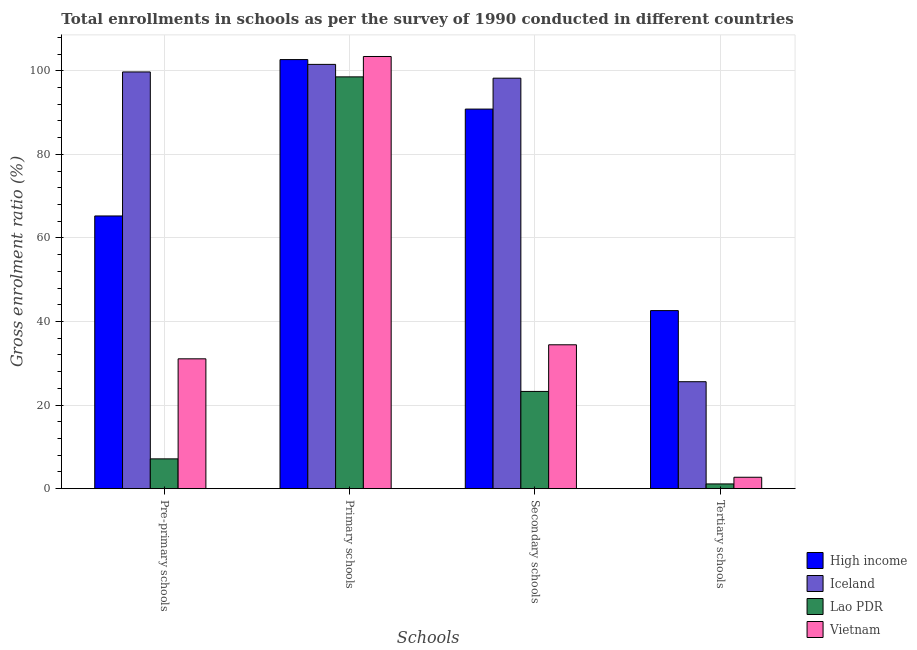Are the number of bars per tick equal to the number of legend labels?
Keep it short and to the point. Yes. How many bars are there on the 2nd tick from the left?
Provide a succinct answer. 4. What is the label of the 4th group of bars from the left?
Your answer should be very brief. Tertiary schools. What is the gross enrolment ratio in secondary schools in Iceland?
Offer a terse response. 98.23. Across all countries, what is the maximum gross enrolment ratio in pre-primary schools?
Ensure brevity in your answer.  99.72. Across all countries, what is the minimum gross enrolment ratio in tertiary schools?
Provide a succinct answer. 1.13. In which country was the gross enrolment ratio in tertiary schools maximum?
Ensure brevity in your answer.  High income. In which country was the gross enrolment ratio in secondary schools minimum?
Give a very brief answer. Lao PDR. What is the total gross enrolment ratio in primary schools in the graph?
Make the answer very short. 406.16. What is the difference between the gross enrolment ratio in pre-primary schools in Lao PDR and that in Vietnam?
Offer a very short reply. -23.94. What is the difference between the gross enrolment ratio in primary schools in Iceland and the gross enrolment ratio in pre-primary schools in High income?
Your response must be concise. 36.27. What is the average gross enrolment ratio in tertiary schools per country?
Provide a short and direct response. 18.02. What is the difference between the gross enrolment ratio in primary schools and gross enrolment ratio in tertiary schools in High income?
Your answer should be very brief. 60.06. What is the ratio of the gross enrolment ratio in secondary schools in Iceland to that in Vietnam?
Your answer should be compact. 2.85. What is the difference between the highest and the second highest gross enrolment ratio in primary schools?
Offer a terse response. 0.74. What is the difference between the highest and the lowest gross enrolment ratio in tertiary schools?
Provide a short and direct response. 41.48. Is the sum of the gross enrolment ratio in secondary schools in Vietnam and Iceland greater than the maximum gross enrolment ratio in pre-primary schools across all countries?
Keep it short and to the point. Yes. Is it the case that in every country, the sum of the gross enrolment ratio in tertiary schools and gross enrolment ratio in secondary schools is greater than the sum of gross enrolment ratio in pre-primary schools and gross enrolment ratio in primary schools?
Your response must be concise. No. What does the 4th bar from the left in Primary schools represents?
Keep it short and to the point. Vietnam. What does the 2nd bar from the right in Tertiary schools represents?
Offer a very short reply. Lao PDR. Are the values on the major ticks of Y-axis written in scientific E-notation?
Provide a short and direct response. No. Does the graph contain grids?
Offer a terse response. Yes. Where does the legend appear in the graph?
Ensure brevity in your answer.  Bottom right. How many legend labels are there?
Your response must be concise. 4. How are the legend labels stacked?
Make the answer very short. Vertical. What is the title of the graph?
Ensure brevity in your answer.  Total enrollments in schools as per the survey of 1990 conducted in different countries. Does "Sudan" appear as one of the legend labels in the graph?
Offer a terse response. No. What is the label or title of the X-axis?
Your answer should be compact. Schools. What is the Gross enrolment ratio (%) of High income in Pre-primary schools?
Provide a succinct answer. 65.26. What is the Gross enrolment ratio (%) in Iceland in Pre-primary schools?
Your response must be concise. 99.72. What is the Gross enrolment ratio (%) of Lao PDR in Pre-primary schools?
Make the answer very short. 7.13. What is the Gross enrolment ratio (%) in Vietnam in Pre-primary schools?
Keep it short and to the point. 31.07. What is the Gross enrolment ratio (%) in High income in Primary schools?
Give a very brief answer. 102.68. What is the Gross enrolment ratio (%) in Iceland in Primary schools?
Offer a very short reply. 101.53. What is the Gross enrolment ratio (%) in Lao PDR in Primary schools?
Your response must be concise. 98.54. What is the Gross enrolment ratio (%) in Vietnam in Primary schools?
Provide a short and direct response. 103.42. What is the Gross enrolment ratio (%) in High income in Secondary schools?
Your answer should be compact. 90.83. What is the Gross enrolment ratio (%) of Iceland in Secondary schools?
Make the answer very short. 98.23. What is the Gross enrolment ratio (%) of Lao PDR in Secondary schools?
Provide a short and direct response. 23.27. What is the Gross enrolment ratio (%) of Vietnam in Secondary schools?
Offer a terse response. 34.43. What is the Gross enrolment ratio (%) of High income in Tertiary schools?
Offer a very short reply. 42.61. What is the Gross enrolment ratio (%) in Iceland in Tertiary schools?
Your answer should be compact. 25.6. What is the Gross enrolment ratio (%) in Lao PDR in Tertiary schools?
Offer a terse response. 1.13. What is the Gross enrolment ratio (%) in Vietnam in Tertiary schools?
Offer a terse response. 2.73. Across all Schools, what is the maximum Gross enrolment ratio (%) in High income?
Provide a short and direct response. 102.68. Across all Schools, what is the maximum Gross enrolment ratio (%) in Iceland?
Offer a very short reply. 101.53. Across all Schools, what is the maximum Gross enrolment ratio (%) in Lao PDR?
Your response must be concise. 98.54. Across all Schools, what is the maximum Gross enrolment ratio (%) in Vietnam?
Provide a succinct answer. 103.42. Across all Schools, what is the minimum Gross enrolment ratio (%) of High income?
Offer a very short reply. 42.61. Across all Schools, what is the minimum Gross enrolment ratio (%) of Iceland?
Offer a very short reply. 25.6. Across all Schools, what is the minimum Gross enrolment ratio (%) in Lao PDR?
Provide a succinct answer. 1.13. Across all Schools, what is the minimum Gross enrolment ratio (%) in Vietnam?
Provide a succinct answer. 2.73. What is the total Gross enrolment ratio (%) of High income in the graph?
Provide a short and direct response. 301.38. What is the total Gross enrolment ratio (%) of Iceland in the graph?
Give a very brief answer. 325.07. What is the total Gross enrolment ratio (%) in Lao PDR in the graph?
Keep it short and to the point. 130.08. What is the total Gross enrolment ratio (%) in Vietnam in the graph?
Provide a short and direct response. 171.65. What is the difference between the Gross enrolment ratio (%) in High income in Pre-primary schools and that in Primary schools?
Give a very brief answer. -37.42. What is the difference between the Gross enrolment ratio (%) in Iceland in Pre-primary schools and that in Primary schools?
Provide a succinct answer. -1.81. What is the difference between the Gross enrolment ratio (%) in Lao PDR in Pre-primary schools and that in Primary schools?
Provide a succinct answer. -91.41. What is the difference between the Gross enrolment ratio (%) in Vietnam in Pre-primary schools and that in Primary schools?
Provide a short and direct response. -72.34. What is the difference between the Gross enrolment ratio (%) of High income in Pre-primary schools and that in Secondary schools?
Keep it short and to the point. -25.58. What is the difference between the Gross enrolment ratio (%) of Iceland in Pre-primary schools and that in Secondary schools?
Give a very brief answer. 1.49. What is the difference between the Gross enrolment ratio (%) in Lao PDR in Pre-primary schools and that in Secondary schools?
Offer a terse response. -16.14. What is the difference between the Gross enrolment ratio (%) in Vietnam in Pre-primary schools and that in Secondary schools?
Offer a terse response. -3.36. What is the difference between the Gross enrolment ratio (%) of High income in Pre-primary schools and that in Tertiary schools?
Keep it short and to the point. 22.64. What is the difference between the Gross enrolment ratio (%) of Iceland in Pre-primary schools and that in Tertiary schools?
Keep it short and to the point. 74.12. What is the difference between the Gross enrolment ratio (%) of Lao PDR in Pre-primary schools and that in Tertiary schools?
Provide a succinct answer. 6. What is the difference between the Gross enrolment ratio (%) in Vietnam in Pre-primary schools and that in Tertiary schools?
Keep it short and to the point. 28.34. What is the difference between the Gross enrolment ratio (%) of High income in Primary schools and that in Secondary schools?
Provide a short and direct response. 11.85. What is the difference between the Gross enrolment ratio (%) in Iceland in Primary schools and that in Secondary schools?
Offer a very short reply. 3.3. What is the difference between the Gross enrolment ratio (%) of Lao PDR in Primary schools and that in Secondary schools?
Provide a succinct answer. 75.27. What is the difference between the Gross enrolment ratio (%) of Vietnam in Primary schools and that in Secondary schools?
Provide a short and direct response. 68.99. What is the difference between the Gross enrolment ratio (%) in High income in Primary schools and that in Tertiary schools?
Offer a very short reply. 60.06. What is the difference between the Gross enrolment ratio (%) of Iceland in Primary schools and that in Tertiary schools?
Offer a terse response. 75.93. What is the difference between the Gross enrolment ratio (%) of Lao PDR in Primary schools and that in Tertiary schools?
Your answer should be very brief. 97.4. What is the difference between the Gross enrolment ratio (%) in Vietnam in Primary schools and that in Tertiary schools?
Your answer should be compact. 100.69. What is the difference between the Gross enrolment ratio (%) in High income in Secondary schools and that in Tertiary schools?
Your response must be concise. 48.22. What is the difference between the Gross enrolment ratio (%) of Iceland in Secondary schools and that in Tertiary schools?
Ensure brevity in your answer.  72.63. What is the difference between the Gross enrolment ratio (%) in Lao PDR in Secondary schools and that in Tertiary schools?
Your response must be concise. 22.14. What is the difference between the Gross enrolment ratio (%) in Vietnam in Secondary schools and that in Tertiary schools?
Your answer should be compact. 31.7. What is the difference between the Gross enrolment ratio (%) in High income in Pre-primary schools and the Gross enrolment ratio (%) in Iceland in Primary schools?
Offer a terse response. -36.27. What is the difference between the Gross enrolment ratio (%) of High income in Pre-primary schools and the Gross enrolment ratio (%) of Lao PDR in Primary schools?
Make the answer very short. -33.28. What is the difference between the Gross enrolment ratio (%) of High income in Pre-primary schools and the Gross enrolment ratio (%) of Vietnam in Primary schools?
Your response must be concise. -38.16. What is the difference between the Gross enrolment ratio (%) in Iceland in Pre-primary schools and the Gross enrolment ratio (%) in Lao PDR in Primary schools?
Provide a short and direct response. 1.18. What is the difference between the Gross enrolment ratio (%) of Iceland in Pre-primary schools and the Gross enrolment ratio (%) of Vietnam in Primary schools?
Offer a very short reply. -3.7. What is the difference between the Gross enrolment ratio (%) in Lao PDR in Pre-primary schools and the Gross enrolment ratio (%) in Vietnam in Primary schools?
Keep it short and to the point. -96.28. What is the difference between the Gross enrolment ratio (%) of High income in Pre-primary schools and the Gross enrolment ratio (%) of Iceland in Secondary schools?
Keep it short and to the point. -32.97. What is the difference between the Gross enrolment ratio (%) in High income in Pre-primary schools and the Gross enrolment ratio (%) in Lao PDR in Secondary schools?
Make the answer very short. 41.99. What is the difference between the Gross enrolment ratio (%) in High income in Pre-primary schools and the Gross enrolment ratio (%) in Vietnam in Secondary schools?
Your answer should be compact. 30.83. What is the difference between the Gross enrolment ratio (%) in Iceland in Pre-primary schools and the Gross enrolment ratio (%) in Lao PDR in Secondary schools?
Offer a very short reply. 76.45. What is the difference between the Gross enrolment ratio (%) of Iceland in Pre-primary schools and the Gross enrolment ratio (%) of Vietnam in Secondary schools?
Your answer should be very brief. 65.29. What is the difference between the Gross enrolment ratio (%) of Lao PDR in Pre-primary schools and the Gross enrolment ratio (%) of Vietnam in Secondary schools?
Give a very brief answer. -27.3. What is the difference between the Gross enrolment ratio (%) of High income in Pre-primary schools and the Gross enrolment ratio (%) of Iceland in Tertiary schools?
Keep it short and to the point. 39.66. What is the difference between the Gross enrolment ratio (%) of High income in Pre-primary schools and the Gross enrolment ratio (%) of Lao PDR in Tertiary schools?
Offer a very short reply. 64.12. What is the difference between the Gross enrolment ratio (%) of High income in Pre-primary schools and the Gross enrolment ratio (%) of Vietnam in Tertiary schools?
Offer a very short reply. 62.52. What is the difference between the Gross enrolment ratio (%) in Iceland in Pre-primary schools and the Gross enrolment ratio (%) in Lao PDR in Tertiary schools?
Offer a very short reply. 98.58. What is the difference between the Gross enrolment ratio (%) in Iceland in Pre-primary schools and the Gross enrolment ratio (%) in Vietnam in Tertiary schools?
Ensure brevity in your answer.  96.99. What is the difference between the Gross enrolment ratio (%) of Lao PDR in Pre-primary schools and the Gross enrolment ratio (%) of Vietnam in Tertiary schools?
Provide a short and direct response. 4.4. What is the difference between the Gross enrolment ratio (%) of High income in Primary schools and the Gross enrolment ratio (%) of Iceland in Secondary schools?
Your answer should be compact. 4.45. What is the difference between the Gross enrolment ratio (%) in High income in Primary schools and the Gross enrolment ratio (%) in Lao PDR in Secondary schools?
Make the answer very short. 79.41. What is the difference between the Gross enrolment ratio (%) in High income in Primary schools and the Gross enrolment ratio (%) in Vietnam in Secondary schools?
Your response must be concise. 68.25. What is the difference between the Gross enrolment ratio (%) in Iceland in Primary schools and the Gross enrolment ratio (%) in Lao PDR in Secondary schools?
Your answer should be compact. 78.26. What is the difference between the Gross enrolment ratio (%) of Iceland in Primary schools and the Gross enrolment ratio (%) of Vietnam in Secondary schools?
Provide a succinct answer. 67.1. What is the difference between the Gross enrolment ratio (%) in Lao PDR in Primary schools and the Gross enrolment ratio (%) in Vietnam in Secondary schools?
Your response must be concise. 64.11. What is the difference between the Gross enrolment ratio (%) of High income in Primary schools and the Gross enrolment ratio (%) of Iceland in Tertiary schools?
Your response must be concise. 77.08. What is the difference between the Gross enrolment ratio (%) in High income in Primary schools and the Gross enrolment ratio (%) in Lao PDR in Tertiary schools?
Make the answer very short. 101.54. What is the difference between the Gross enrolment ratio (%) in High income in Primary schools and the Gross enrolment ratio (%) in Vietnam in Tertiary schools?
Your response must be concise. 99.95. What is the difference between the Gross enrolment ratio (%) in Iceland in Primary schools and the Gross enrolment ratio (%) in Lao PDR in Tertiary schools?
Make the answer very short. 100.39. What is the difference between the Gross enrolment ratio (%) in Iceland in Primary schools and the Gross enrolment ratio (%) in Vietnam in Tertiary schools?
Give a very brief answer. 98.8. What is the difference between the Gross enrolment ratio (%) in Lao PDR in Primary schools and the Gross enrolment ratio (%) in Vietnam in Tertiary schools?
Offer a very short reply. 95.81. What is the difference between the Gross enrolment ratio (%) in High income in Secondary schools and the Gross enrolment ratio (%) in Iceland in Tertiary schools?
Your answer should be compact. 65.24. What is the difference between the Gross enrolment ratio (%) in High income in Secondary schools and the Gross enrolment ratio (%) in Lao PDR in Tertiary schools?
Your answer should be very brief. 89.7. What is the difference between the Gross enrolment ratio (%) in High income in Secondary schools and the Gross enrolment ratio (%) in Vietnam in Tertiary schools?
Provide a succinct answer. 88.1. What is the difference between the Gross enrolment ratio (%) in Iceland in Secondary schools and the Gross enrolment ratio (%) in Lao PDR in Tertiary schools?
Your answer should be compact. 97.09. What is the difference between the Gross enrolment ratio (%) in Iceland in Secondary schools and the Gross enrolment ratio (%) in Vietnam in Tertiary schools?
Keep it short and to the point. 95.49. What is the difference between the Gross enrolment ratio (%) in Lao PDR in Secondary schools and the Gross enrolment ratio (%) in Vietnam in Tertiary schools?
Offer a very short reply. 20.54. What is the average Gross enrolment ratio (%) in High income per Schools?
Your answer should be very brief. 75.34. What is the average Gross enrolment ratio (%) of Iceland per Schools?
Make the answer very short. 81.27. What is the average Gross enrolment ratio (%) of Lao PDR per Schools?
Ensure brevity in your answer.  32.52. What is the average Gross enrolment ratio (%) in Vietnam per Schools?
Provide a short and direct response. 42.91. What is the difference between the Gross enrolment ratio (%) in High income and Gross enrolment ratio (%) in Iceland in Pre-primary schools?
Offer a very short reply. -34.46. What is the difference between the Gross enrolment ratio (%) of High income and Gross enrolment ratio (%) of Lao PDR in Pre-primary schools?
Ensure brevity in your answer.  58.12. What is the difference between the Gross enrolment ratio (%) in High income and Gross enrolment ratio (%) in Vietnam in Pre-primary schools?
Offer a terse response. 34.18. What is the difference between the Gross enrolment ratio (%) of Iceland and Gross enrolment ratio (%) of Lao PDR in Pre-primary schools?
Your answer should be very brief. 92.58. What is the difference between the Gross enrolment ratio (%) of Iceland and Gross enrolment ratio (%) of Vietnam in Pre-primary schools?
Your response must be concise. 68.64. What is the difference between the Gross enrolment ratio (%) of Lao PDR and Gross enrolment ratio (%) of Vietnam in Pre-primary schools?
Offer a very short reply. -23.94. What is the difference between the Gross enrolment ratio (%) in High income and Gross enrolment ratio (%) in Iceland in Primary schools?
Ensure brevity in your answer.  1.15. What is the difference between the Gross enrolment ratio (%) in High income and Gross enrolment ratio (%) in Lao PDR in Primary schools?
Make the answer very short. 4.14. What is the difference between the Gross enrolment ratio (%) of High income and Gross enrolment ratio (%) of Vietnam in Primary schools?
Provide a succinct answer. -0.74. What is the difference between the Gross enrolment ratio (%) of Iceland and Gross enrolment ratio (%) of Lao PDR in Primary schools?
Provide a short and direct response. 2.99. What is the difference between the Gross enrolment ratio (%) in Iceland and Gross enrolment ratio (%) in Vietnam in Primary schools?
Make the answer very short. -1.89. What is the difference between the Gross enrolment ratio (%) of Lao PDR and Gross enrolment ratio (%) of Vietnam in Primary schools?
Offer a terse response. -4.88. What is the difference between the Gross enrolment ratio (%) in High income and Gross enrolment ratio (%) in Iceland in Secondary schools?
Your answer should be compact. -7.39. What is the difference between the Gross enrolment ratio (%) of High income and Gross enrolment ratio (%) of Lao PDR in Secondary schools?
Ensure brevity in your answer.  67.56. What is the difference between the Gross enrolment ratio (%) in High income and Gross enrolment ratio (%) in Vietnam in Secondary schools?
Offer a terse response. 56.4. What is the difference between the Gross enrolment ratio (%) of Iceland and Gross enrolment ratio (%) of Lao PDR in Secondary schools?
Make the answer very short. 74.96. What is the difference between the Gross enrolment ratio (%) in Iceland and Gross enrolment ratio (%) in Vietnam in Secondary schools?
Ensure brevity in your answer.  63.8. What is the difference between the Gross enrolment ratio (%) in Lao PDR and Gross enrolment ratio (%) in Vietnam in Secondary schools?
Provide a succinct answer. -11.16. What is the difference between the Gross enrolment ratio (%) of High income and Gross enrolment ratio (%) of Iceland in Tertiary schools?
Your answer should be very brief. 17.02. What is the difference between the Gross enrolment ratio (%) in High income and Gross enrolment ratio (%) in Lao PDR in Tertiary schools?
Provide a short and direct response. 41.48. What is the difference between the Gross enrolment ratio (%) in High income and Gross enrolment ratio (%) in Vietnam in Tertiary schools?
Give a very brief answer. 39.88. What is the difference between the Gross enrolment ratio (%) of Iceland and Gross enrolment ratio (%) of Lao PDR in Tertiary schools?
Make the answer very short. 24.46. What is the difference between the Gross enrolment ratio (%) in Iceland and Gross enrolment ratio (%) in Vietnam in Tertiary schools?
Offer a very short reply. 22.86. What is the difference between the Gross enrolment ratio (%) of Lao PDR and Gross enrolment ratio (%) of Vietnam in Tertiary schools?
Ensure brevity in your answer.  -1.6. What is the ratio of the Gross enrolment ratio (%) of High income in Pre-primary schools to that in Primary schools?
Your answer should be compact. 0.64. What is the ratio of the Gross enrolment ratio (%) in Iceland in Pre-primary schools to that in Primary schools?
Give a very brief answer. 0.98. What is the ratio of the Gross enrolment ratio (%) of Lao PDR in Pre-primary schools to that in Primary schools?
Ensure brevity in your answer.  0.07. What is the ratio of the Gross enrolment ratio (%) of Vietnam in Pre-primary schools to that in Primary schools?
Your answer should be very brief. 0.3. What is the ratio of the Gross enrolment ratio (%) in High income in Pre-primary schools to that in Secondary schools?
Ensure brevity in your answer.  0.72. What is the ratio of the Gross enrolment ratio (%) in Iceland in Pre-primary schools to that in Secondary schools?
Offer a very short reply. 1.02. What is the ratio of the Gross enrolment ratio (%) of Lao PDR in Pre-primary schools to that in Secondary schools?
Make the answer very short. 0.31. What is the ratio of the Gross enrolment ratio (%) in Vietnam in Pre-primary schools to that in Secondary schools?
Your response must be concise. 0.9. What is the ratio of the Gross enrolment ratio (%) of High income in Pre-primary schools to that in Tertiary schools?
Your answer should be compact. 1.53. What is the ratio of the Gross enrolment ratio (%) of Iceland in Pre-primary schools to that in Tertiary schools?
Your answer should be compact. 3.9. What is the ratio of the Gross enrolment ratio (%) of Lao PDR in Pre-primary schools to that in Tertiary schools?
Ensure brevity in your answer.  6.29. What is the ratio of the Gross enrolment ratio (%) of Vietnam in Pre-primary schools to that in Tertiary schools?
Your answer should be very brief. 11.38. What is the ratio of the Gross enrolment ratio (%) in High income in Primary schools to that in Secondary schools?
Ensure brevity in your answer.  1.13. What is the ratio of the Gross enrolment ratio (%) in Iceland in Primary schools to that in Secondary schools?
Give a very brief answer. 1.03. What is the ratio of the Gross enrolment ratio (%) in Lao PDR in Primary schools to that in Secondary schools?
Your answer should be very brief. 4.23. What is the ratio of the Gross enrolment ratio (%) of Vietnam in Primary schools to that in Secondary schools?
Offer a very short reply. 3. What is the ratio of the Gross enrolment ratio (%) of High income in Primary schools to that in Tertiary schools?
Make the answer very short. 2.41. What is the ratio of the Gross enrolment ratio (%) in Iceland in Primary schools to that in Tertiary schools?
Keep it short and to the point. 3.97. What is the ratio of the Gross enrolment ratio (%) of Lao PDR in Primary schools to that in Tertiary schools?
Keep it short and to the point. 86.88. What is the ratio of the Gross enrolment ratio (%) of Vietnam in Primary schools to that in Tertiary schools?
Keep it short and to the point. 37.86. What is the ratio of the Gross enrolment ratio (%) of High income in Secondary schools to that in Tertiary schools?
Provide a short and direct response. 2.13. What is the ratio of the Gross enrolment ratio (%) in Iceland in Secondary schools to that in Tertiary schools?
Offer a very short reply. 3.84. What is the ratio of the Gross enrolment ratio (%) in Lao PDR in Secondary schools to that in Tertiary schools?
Provide a short and direct response. 20.52. What is the ratio of the Gross enrolment ratio (%) of Vietnam in Secondary schools to that in Tertiary schools?
Ensure brevity in your answer.  12.6. What is the difference between the highest and the second highest Gross enrolment ratio (%) of High income?
Give a very brief answer. 11.85. What is the difference between the highest and the second highest Gross enrolment ratio (%) in Iceland?
Make the answer very short. 1.81. What is the difference between the highest and the second highest Gross enrolment ratio (%) of Lao PDR?
Ensure brevity in your answer.  75.27. What is the difference between the highest and the second highest Gross enrolment ratio (%) of Vietnam?
Ensure brevity in your answer.  68.99. What is the difference between the highest and the lowest Gross enrolment ratio (%) of High income?
Ensure brevity in your answer.  60.06. What is the difference between the highest and the lowest Gross enrolment ratio (%) in Iceland?
Provide a succinct answer. 75.93. What is the difference between the highest and the lowest Gross enrolment ratio (%) in Lao PDR?
Provide a succinct answer. 97.4. What is the difference between the highest and the lowest Gross enrolment ratio (%) in Vietnam?
Provide a succinct answer. 100.69. 